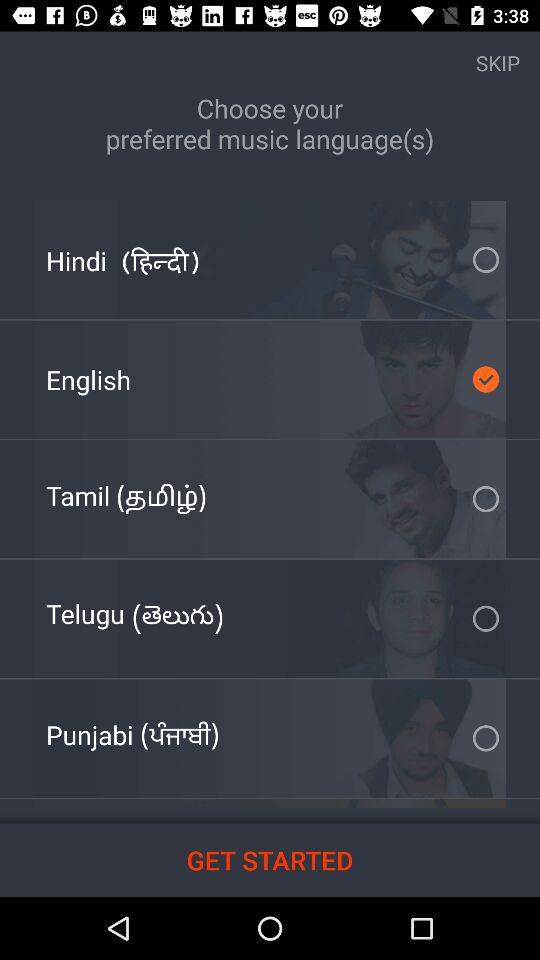How many languages are available to choose from that are not Hindi or English?
Answer the question using a single word or phrase. 3 